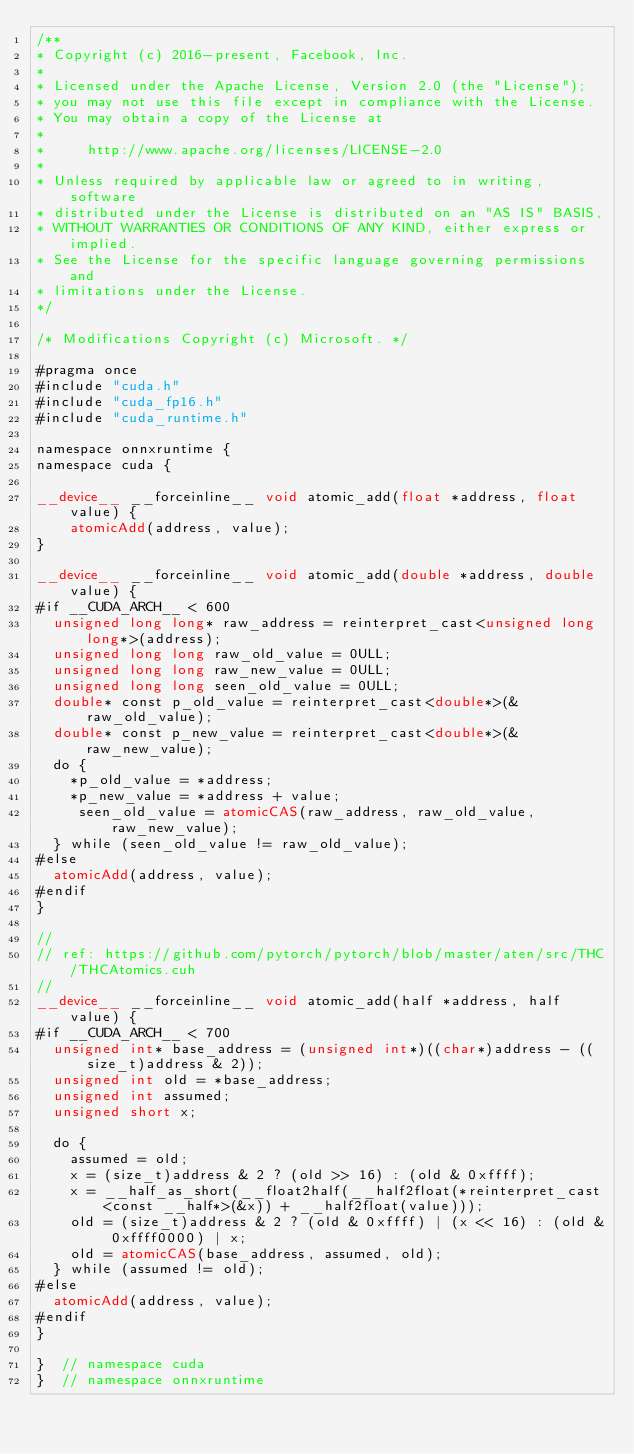Convert code to text. <code><loc_0><loc_0><loc_500><loc_500><_Cuda_>/**
* Copyright (c) 2016-present, Facebook, Inc.
*
* Licensed under the Apache License, Version 2.0 (the "License");
* you may not use this file except in compliance with the License.
* You may obtain a copy of the License at
*
*     http://www.apache.org/licenses/LICENSE-2.0
*
* Unless required by applicable law or agreed to in writing, software
* distributed under the License is distributed on an "AS IS" BASIS,
* WITHOUT WARRANTIES OR CONDITIONS OF ANY KIND, either express or implied.
* See the License for the specific language governing permissions and
* limitations under the License.
*/

/* Modifications Copyright (c) Microsoft. */

#pragma once
#include "cuda.h"
#include "cuda_fp16.h"
#include "cuda_runtime.h"

namespace onnxruntime {
namespace cuda {

__device__ __forceinline__ void atomic_add(float *address, float value) {
    atomicAdd(address, value);
}

__device__ __forceinline__ void atomic_add(double *address, double value) {
#if __CUDA_ARCH__ < 600
  unsigned long long* raw_address = reinterpret_cast<unsigned long long*>(address);
  unsigned long long raw_old_value = 0ULL;
  unsigned long long raw_new_value = 0ULL;
  unsigned long long seen_old_value = 0ULL;
  double* const p_old_value = reinterpret_cast<double*>(&raw_old_value);
  double* const p_new_value = reinterpret_cast<double*>(&raw_new_value);
  do {
    *p_old_value = *address;
    *p_new_value = *address + value;
     seen_old_value = atomicCAS(raw_address, raw_old_value, raw_new_value);
  } while (seen_old_value != raw_old_value);
#else
  atomicAdd(address, value);
#endif
}

//
// ref: https://github.com/pytorch/pytorch/blob/master/aten/src/THC/THCAtomics.cuh
//
__device__ __forceinline__ void atomic_add(half *address, half value) {
#if __CUDA_ARCH__ < 700
  unsigned int* base_address = (unsigned int*)((char*)address - ((size_t)address & 2));
  unsigned int old = *base_address;
  unsigned int assumed;
  unsigned short x;

  do {
    assumed = old;
    x = (size_t)address & 2 ? (old >> 16) : (old & 0xffff);
    x = __half_as_short(__float2half(__half2float(*reinterpret_cast<const __half*>(&x)) + __half2float(value)));
    old = (size_t)address & 2 ? (old & 0xffff) | (x << 16) : (old & 0xffff0000) | x;
    old = atomicCAS(base_address, assumed, old);
  } while (assumed != old);
#else
  atomicAdd(address, value);
#endif
}

}  // namespace cuda
}  // namespace onnxruntime</code> 